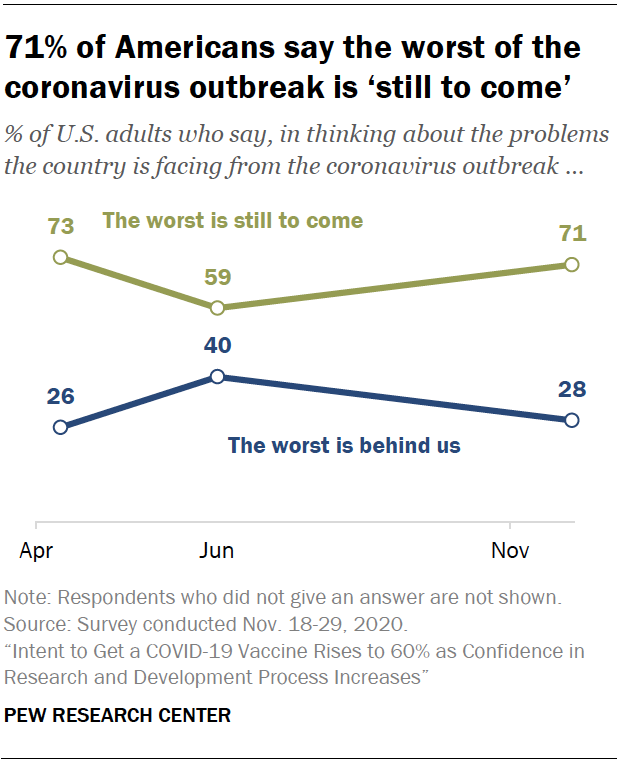Point out several critical features in this image. According to the data, the month that recorded the most optimistic sentiment about the COVID-19 outbreak was June. Six data points are collected. 